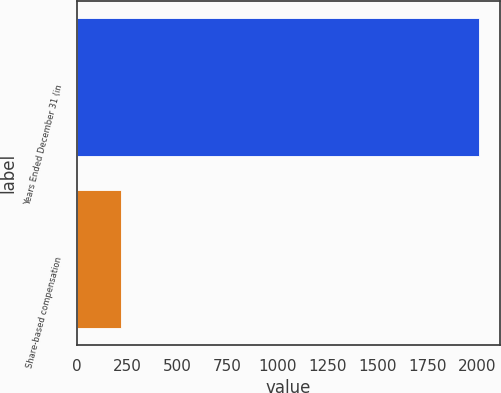Convert chart to OTSL. <chart><loc_0><loc_0><loc_500><loc_500><bar_chart><fcel>Years Ended December 31 (in<fcel>Share-based compensation<nl><fcel>2010<fcel>216<nl></chart> 